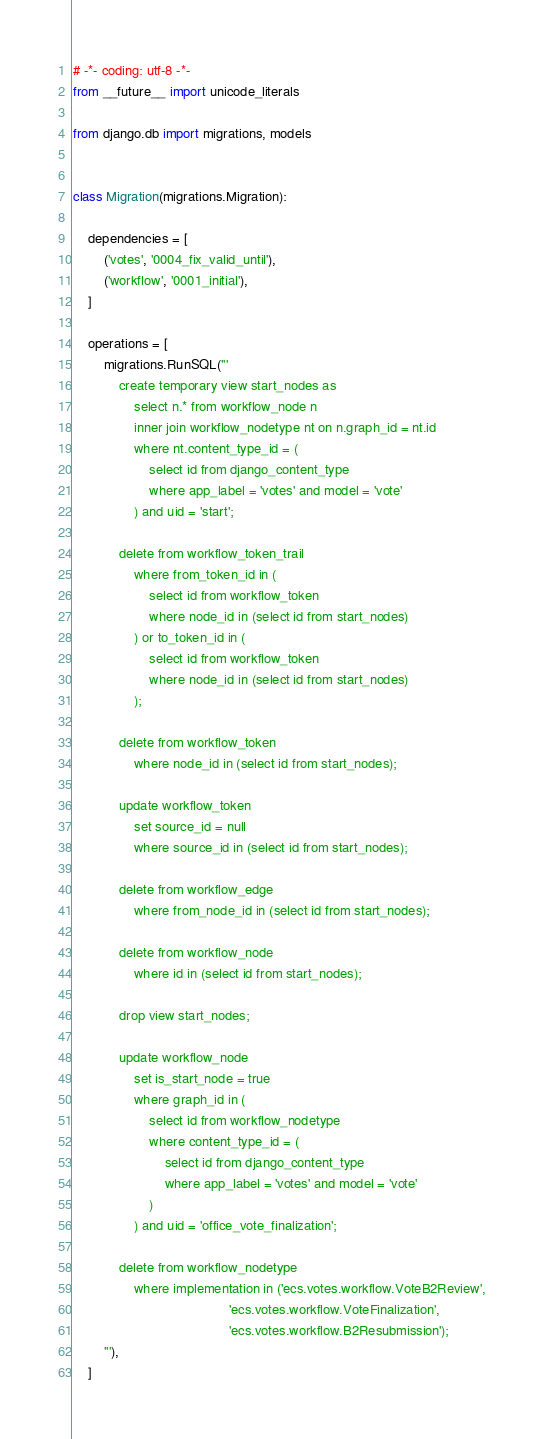Convert code to text. <code><loc_0><loc_0><loc_500><loc_500><_Python_># -*- coding: utf-8 -*-
from __future__ import unicode_literals

from django.db import migrations, models


class Migration(migrations.Migration):

    dependencies = [
        ('votes', '0004_fix_valid_until'),
        ('workflow', '0001_initial'),
    ]

    operations = [
        migrations.RunSQL('''
            create temporary view start_nodes as
                select n.* from workflow_node n
                inner join workflow_nodetype nt on n.graph_id = nt.id
                where nt.content_type_id = (
                    select id from django_content_type
                    where app_label = 'votes' and model = 'vote'
                ) and uid = 'start';

            delete from workflow_token_trail
                where from_token_id in (
                    select id from workflow_token
                    where node_id in (select id from start_nodes)
                ) or to_token_id in (
                    select id from workflow_token
                    where node_id in (select id from start_nodes)
                );

            delete from workflow_token
                where node_id in (select id from start_nodes);

            update workflow_token
                set source_id = null
                where source_id in (select id from start_nodes);

            delete from workflow_edge
                where from_node_id in (select id from start_nodes);

            delete from workflow_node
                where id in (select id from start_nodes);

            drop view start_nodes;

            update workflow_node
                set is_start_node = true
                where graph_id in (
                    select id from workflow_nodetype
                    where content_type_id = (
                        select id from django_content_type
                        where app_label = 'votes' and model = 'vote'
                    )
                ) and uid = 'office_vote_finalization';

            delete from workflow_nodetype
                where implementation in ('ecs.votes.workflow.VoteB2Review',
                                         'ecs.votes.workflow.VoteFinalization',
                                         'ecs.votes.workflow.B2Resubmission');
        '''),
    ]
</code> 